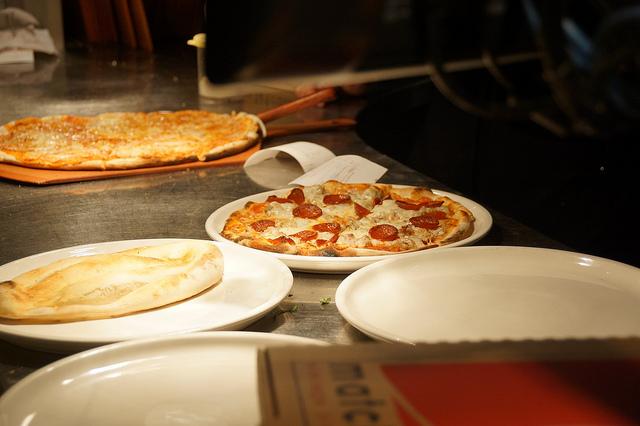How many plates can you see?
Short answer required. 4. Did you eat this pizza before?
Quick response, please. Yes. Are these foods sweet?
Short answer required. No. How many pizzas are there?
Write a very short answer. 2. Is there whip cream smeared on the box?
Short answer required. No. What meal could this be?
Write a very short answer. Dinner. Where is this taken?
Be succinct. Restaurant. 